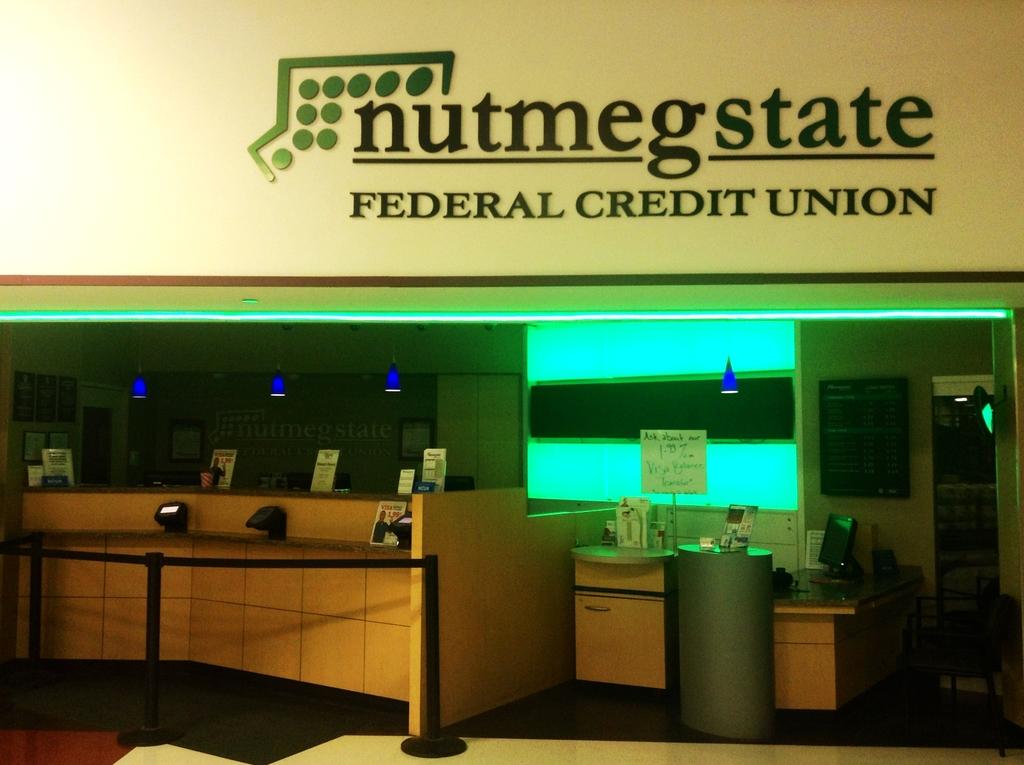What is the name of the federal union?
Ensure brevity in your answer.  Nutmegstate. What is the name of this credit union?
Your answer should be very brief. Nutmeg state. 